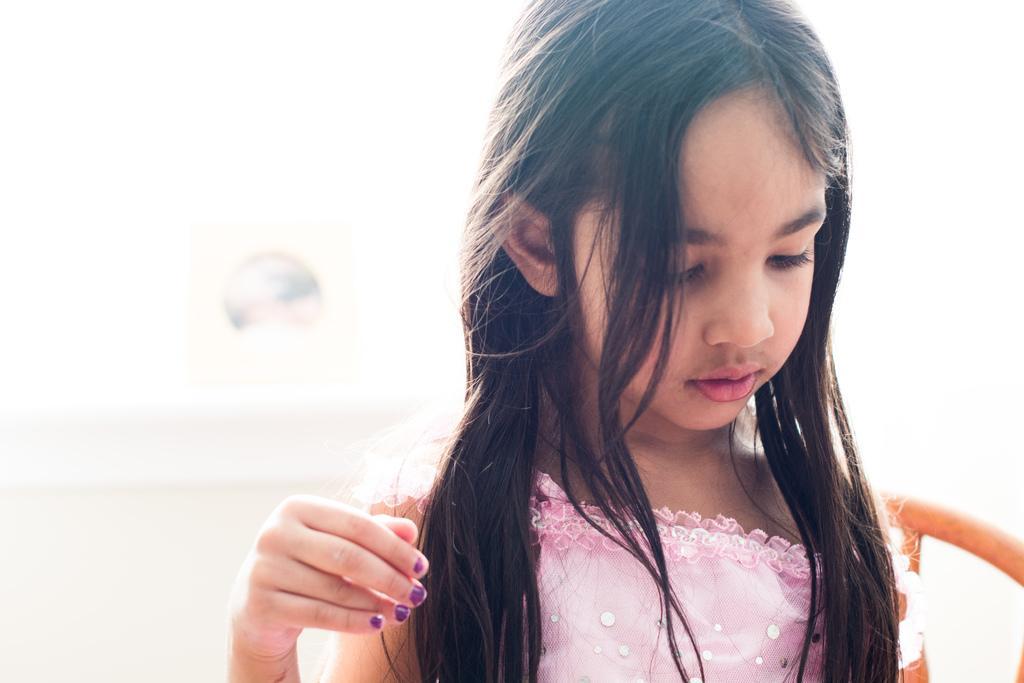Could you give a brief overview of what you see in this image? In this image, we can see a small girl, she is looking down, there is a blur background. 